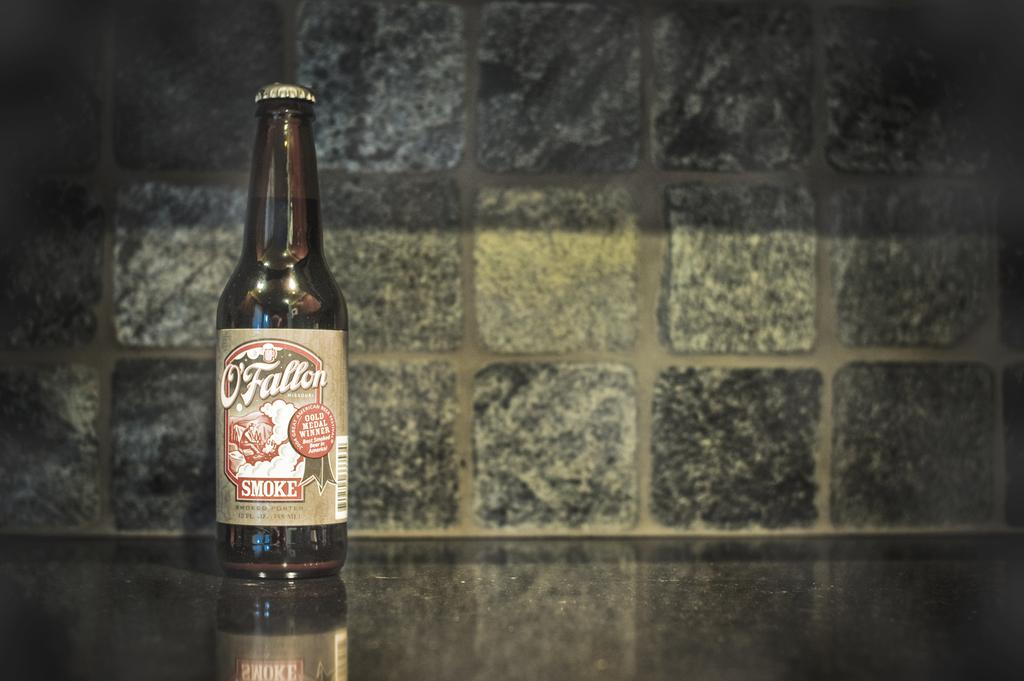<image>
Describe the image concisely. The bottle of O'Fallon was a Gold Medal Winner. 